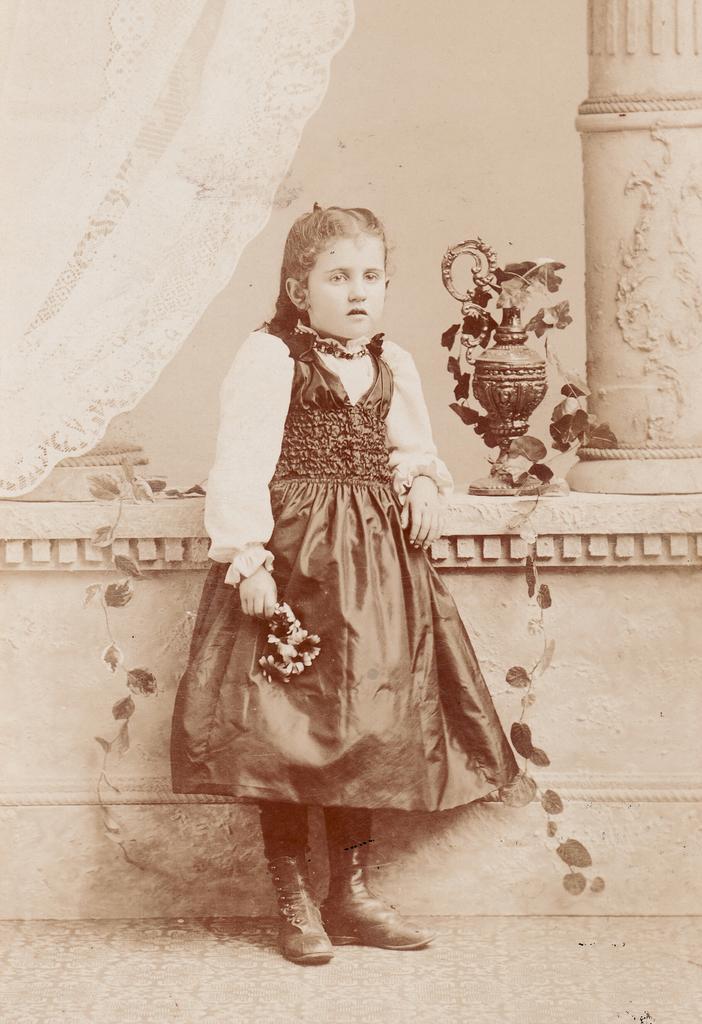Can you describe this image briefly? In this image, we can see a kid wearing clothes and standing in front of the wall. There is a pillar in the top right of the image. There is a curtains in the top left of the image. There is a jar in the middle of the image. 